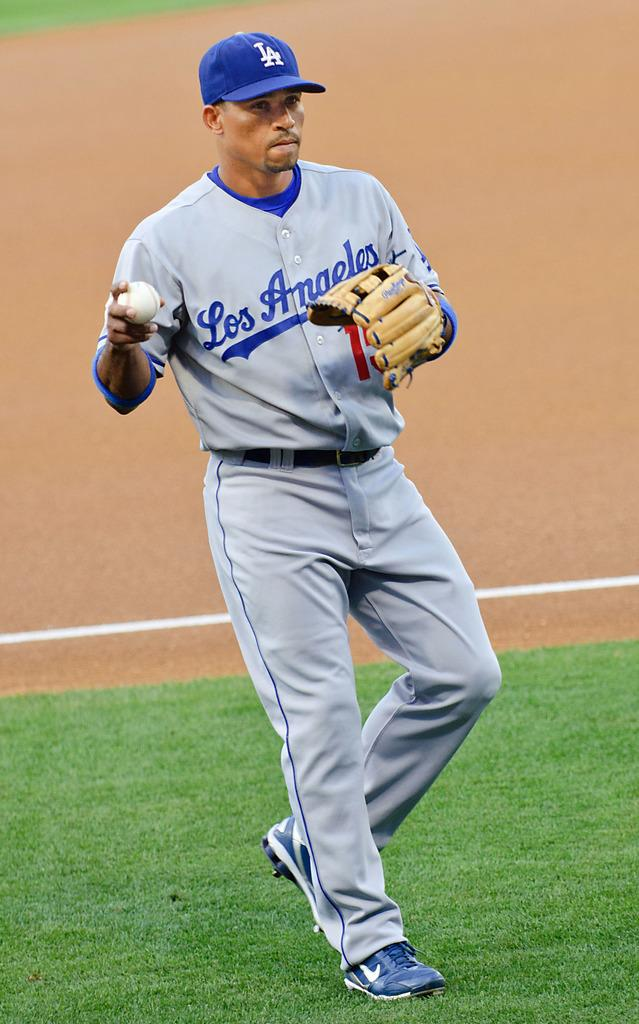<image>
Create a compact narrative representing the image presented. A baseball player for Los Angeles has the ball in his hand. 